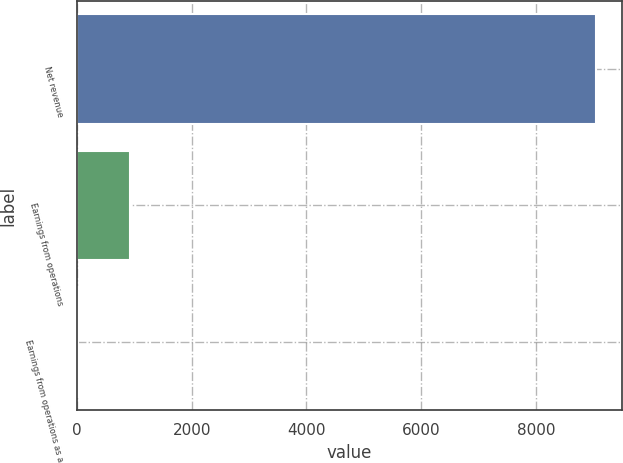<chart> <loc_0><loc_0><loc_500><loc_500><bar_chart><fcel>Net revenue<fcel>Earnings from operations<fcel>Earnings from operations as a<nl><fcel>9052<fcel>914.02<fcel>9.8<nl></chart> 